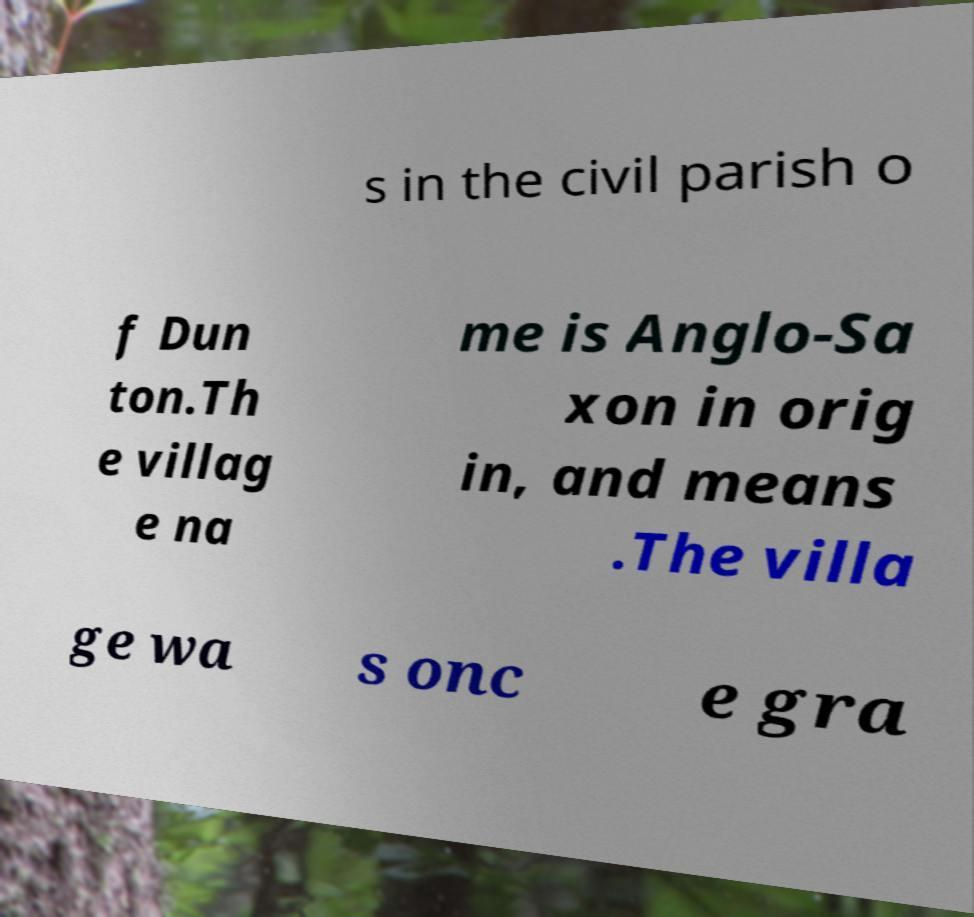For documentation purposes, I need the text within this image transcribed. Could you provide that? s in the civil parish o f Dun ton.Th e villag e na me is Anglo-Sa xon in orig in, and means .The villa ge wa s onc e gra 